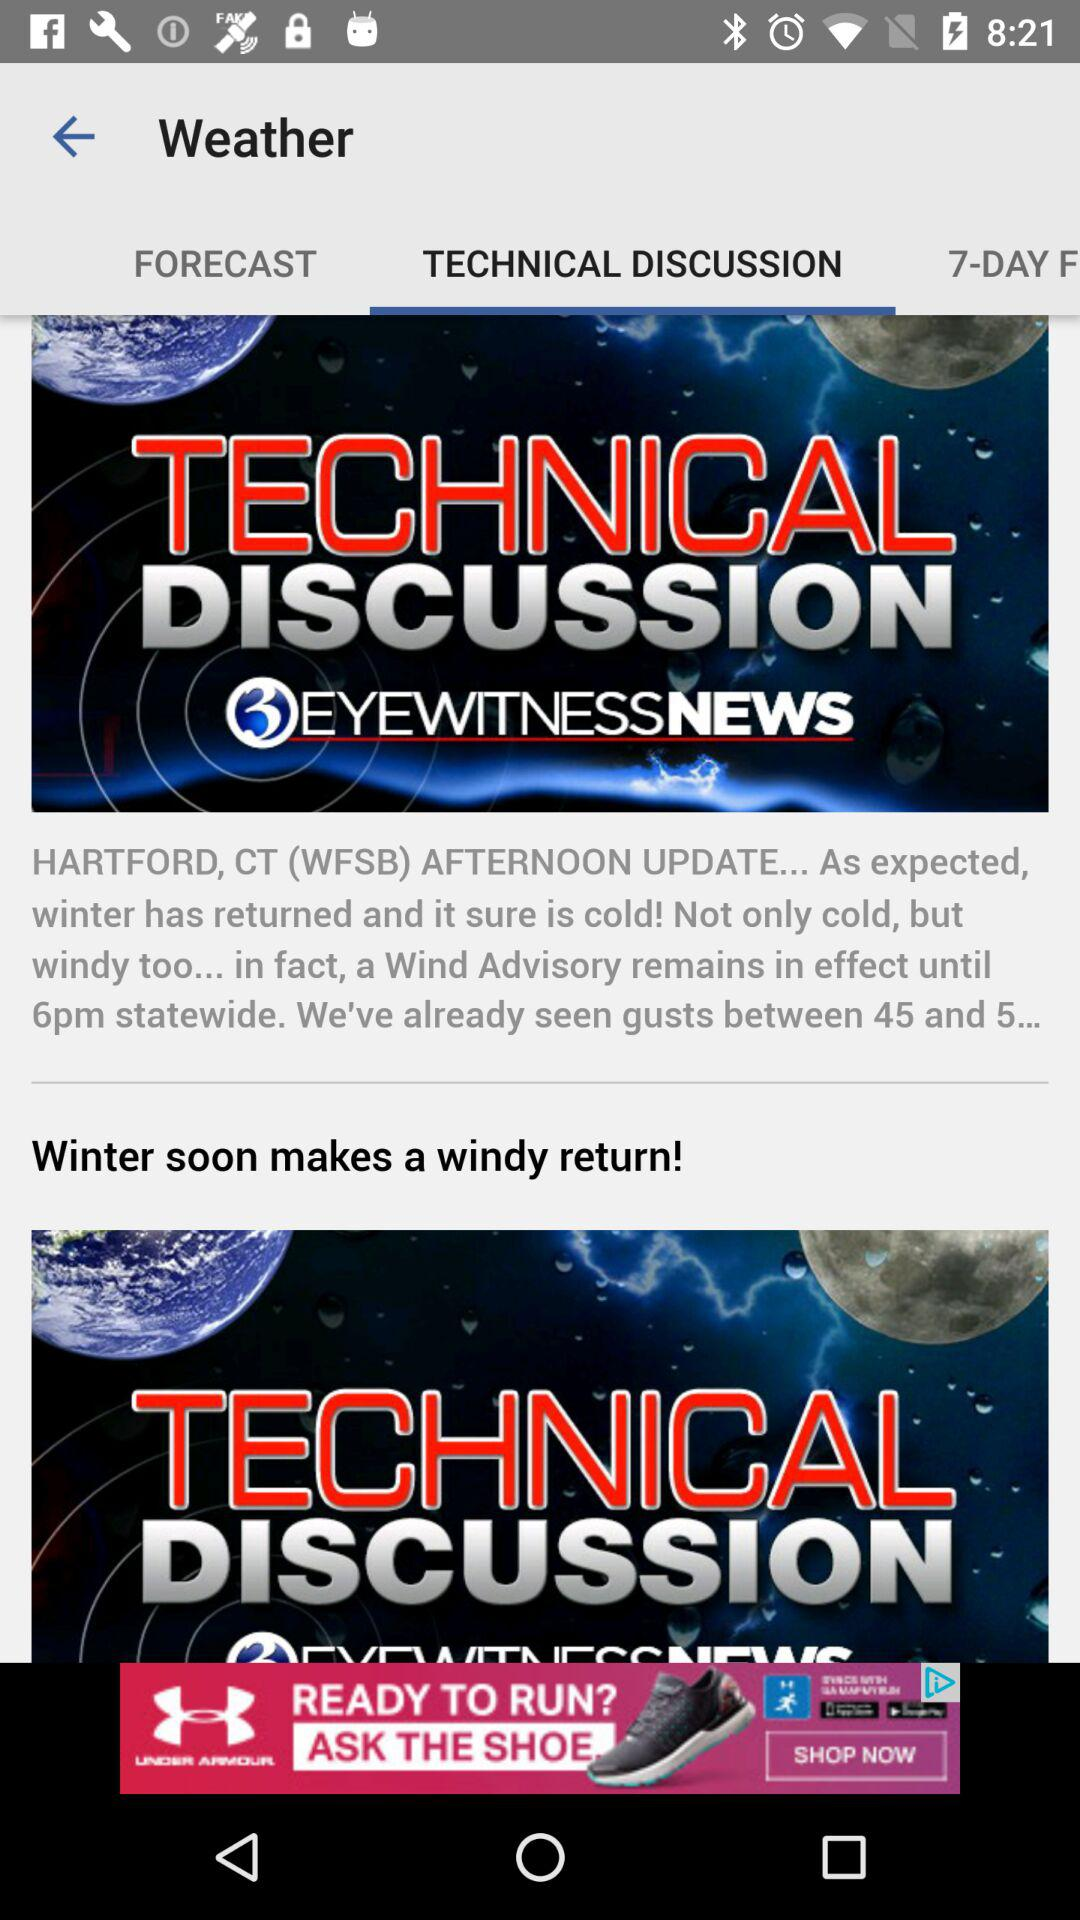Which option is selected in "Weather"? The selected option is "TECHNICAL DISCUSSION". 